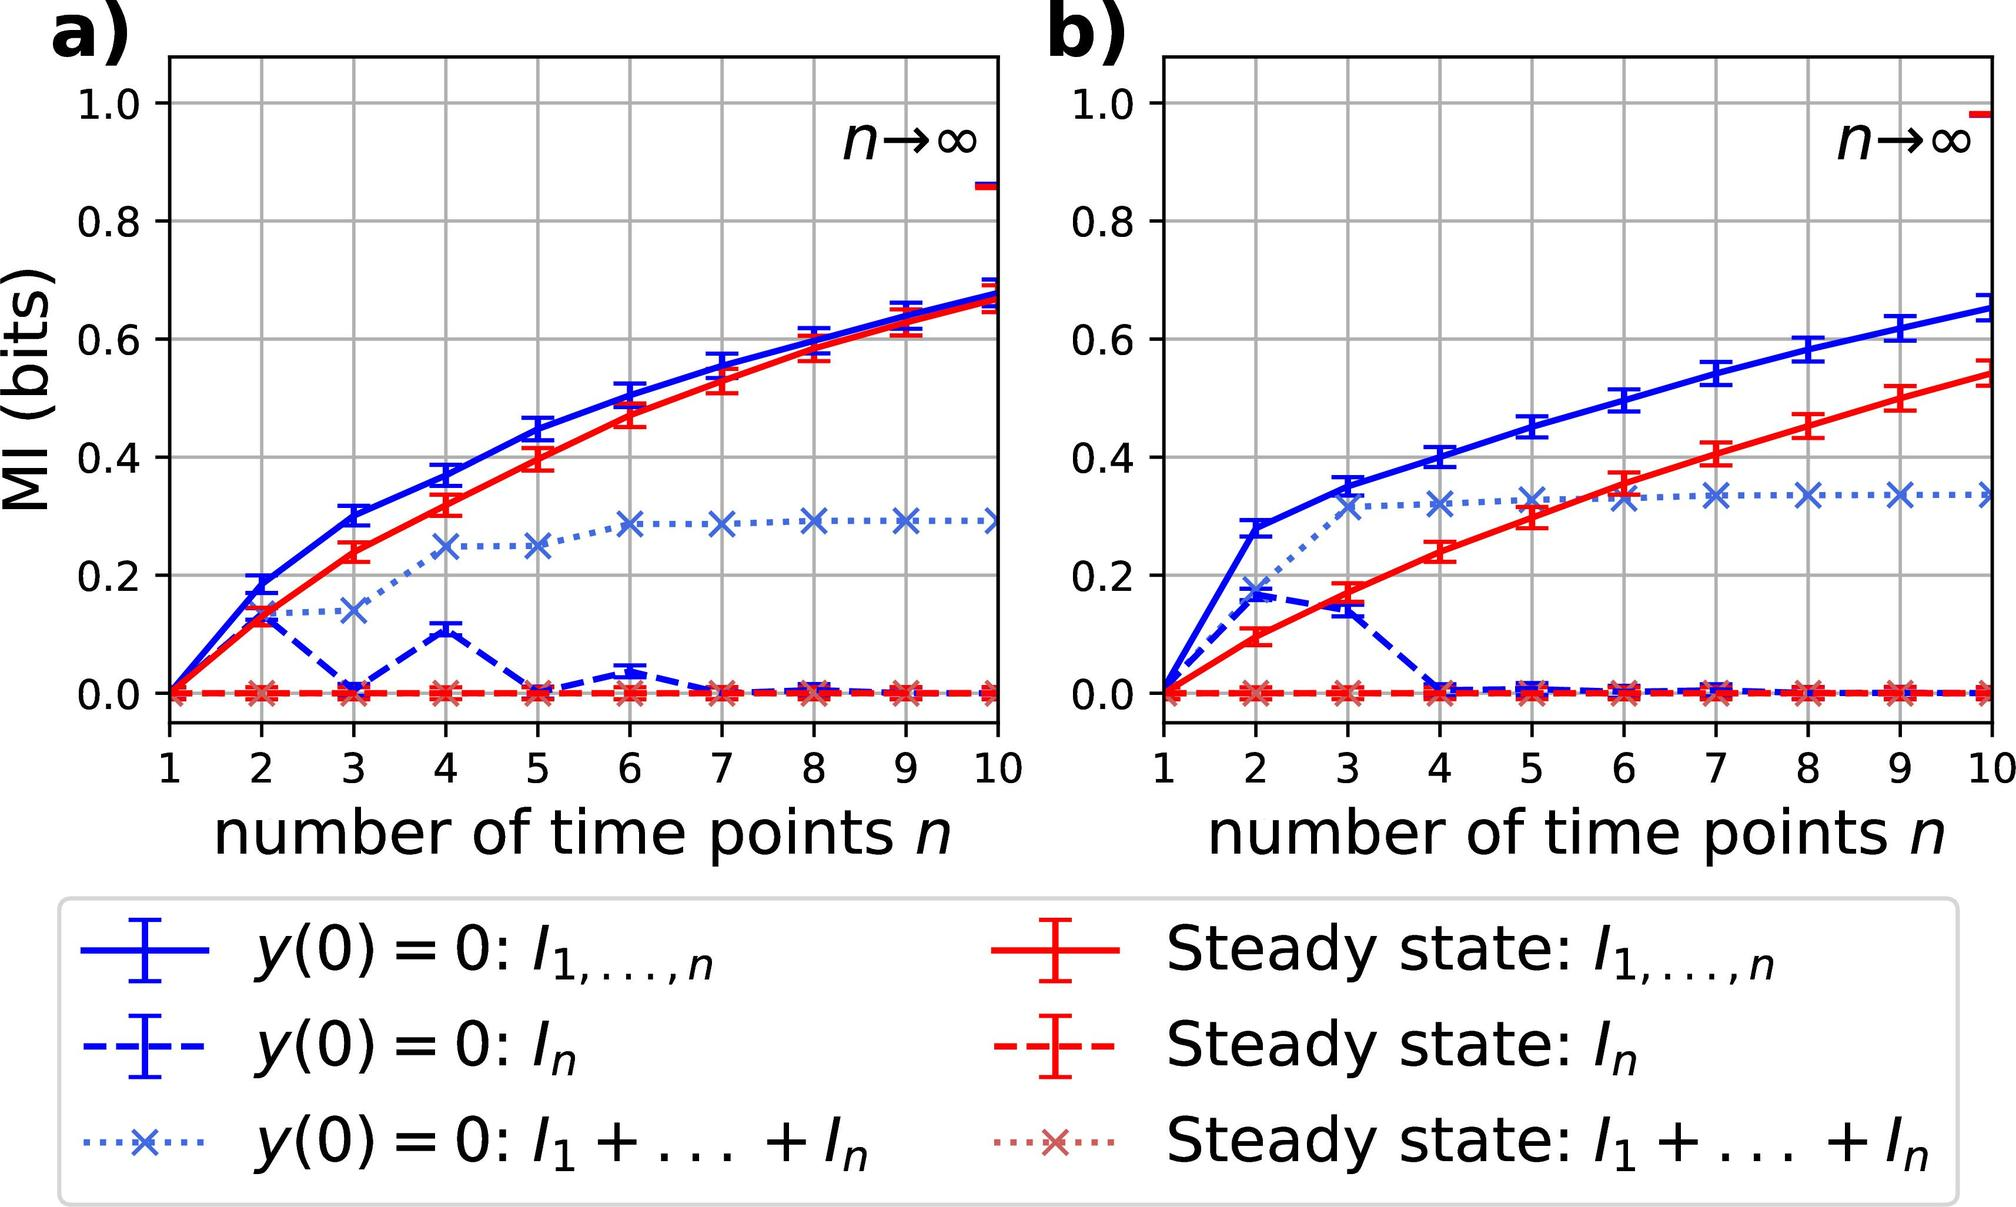Which initial condition in figure a) exhibits the least increase in mutual information (MI) as the number of time points \( n \) increases? A. \( y(0) = 0: l_1, \ldots, n \) B. \( y(0) = 0: I_n \) C. \( y(0) = 0: I_1 + \ldots + I_n \) D. \( y(0) = 0: 1, \ldots, n \) The dotted blue line with 'x' markers in figure a), which corresponds to the initial condition \( y(0) = 0: I_1 + \ldots + I_n \), remains nearly flat as \( n \) increases, indicating a negligible increase in MI. This contrasts with the other conditions, which show a more significant increase. Therefore, the correct answer is C. 